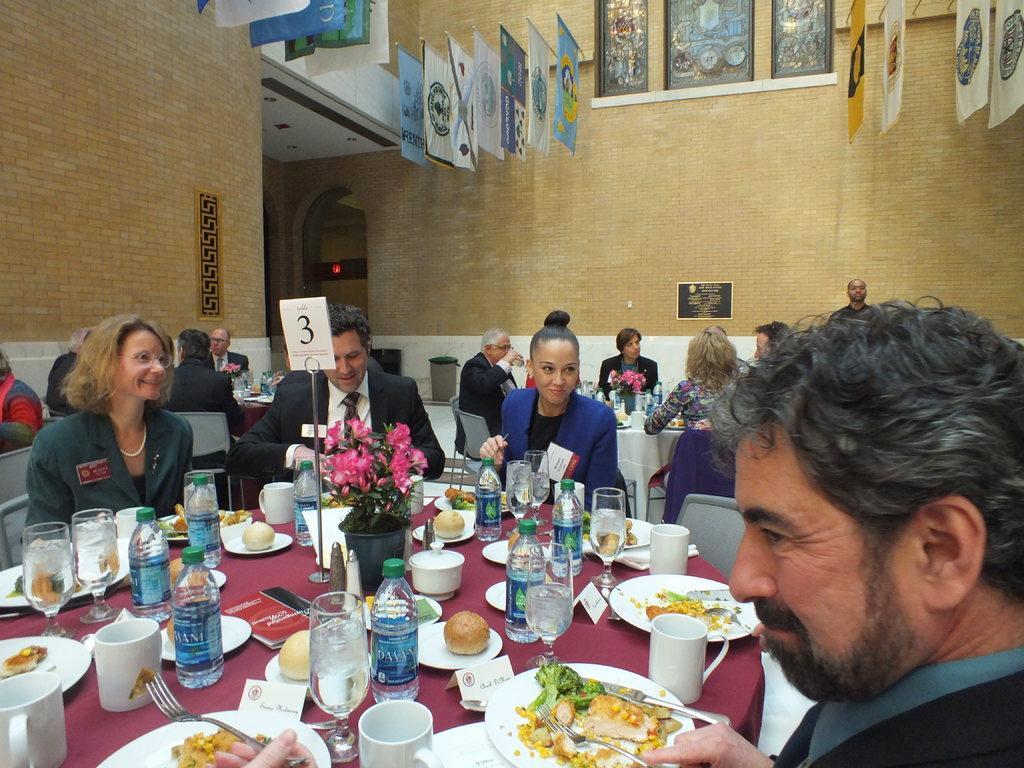Could you give a brief overview of what you see in this image? It seems to be the image is inside the restaurant. In the image there are group of people sitting on chair in front of a table, on table we can see a glass,water bottle,plate,cup,knife,spoon,plant,flower pot, cloth,fork. In background there is a wall and hoardings. 